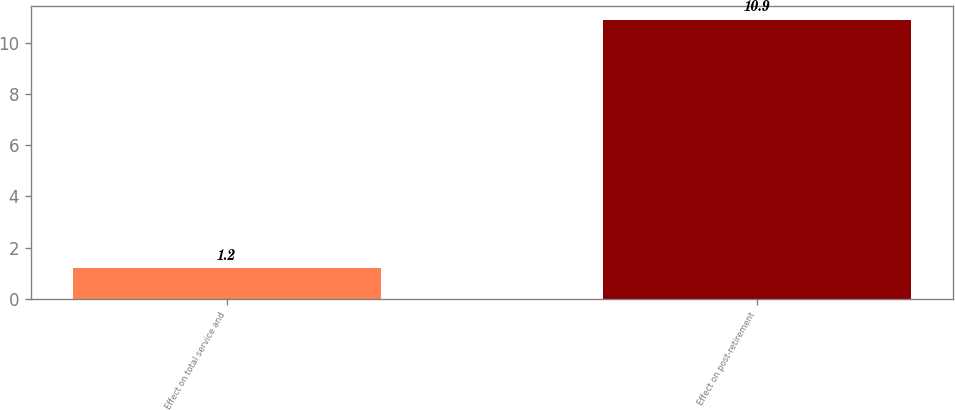Convert chart to OTSL. <chart><loc_0><loc_0><loc_500><loc_500><bar_chart><fcel>Effect on total service and<fcel>Effect on post-retirement<nl><fcel>1.2<fcel>10.9<nl></chart> 